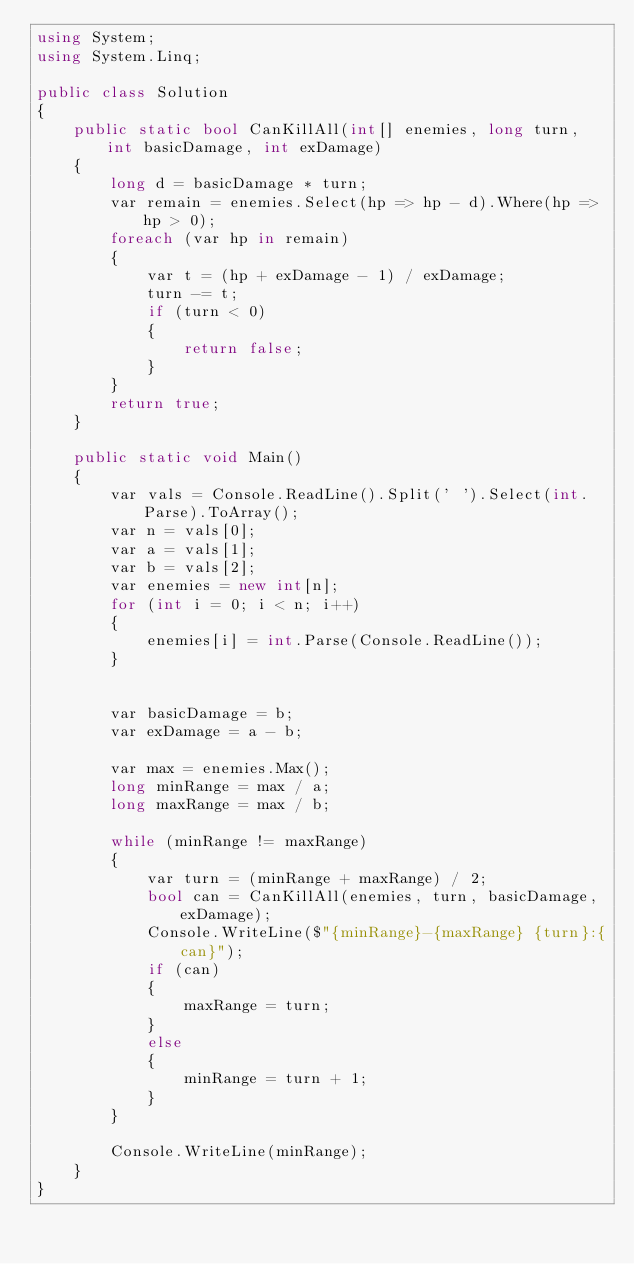Convert code to text. <code><loc_0><loc_0><loc_500><loc_500><_C#_>using System;
using System.Linq;

public class Solution
{
    public static bool CanKillAll(int[] enemies, long turn, int basicDamage, int exDamage)
    {
        long d = basicDamage * turn;
        var remain = enemies.Select(hp => hp - d).Where(hp => hp > 0);
        foreach (var hp in remain)
        {
            var t = (hp + exDamage - 1) / exDamage;
            turn -= t;
            if (turn < 0)
            {
                return false;
            }
        }
        return true;
    }

    public static void Main()
    {
        var vals = Console.ReadLine().Split(' ').Select(int.Parse).ToArray();
        var n = vals[0];
        var a = vals[1];
        var b = vals[2];
        var enemies = new int[n];
        for (int i = 0; i < n; i++)
        {
            enemies[i] = int.Parse(Console.ReadLine());
        }


        var basicDamage = b;
        var exDamage = a - b;

        var max = enemies.Max();
        long minRange = max / a;
        long maxRange = max / b;

        while (minRange != maxRange)
        {
            var turn = (minRange + maxRange) / 2;
            bool can = CanKillAll(enemies, turn, basicDamage, exDamage);
            Console.WriteLine($"{minRange}-{maxRange} {turn}:{can}");
            if (can)
            {
                maxRange = turn;
            }
            else
            {
                minRange = turn + 1;
            }
        }

        Console.WriteLine(minRange);
    }
}</code> 